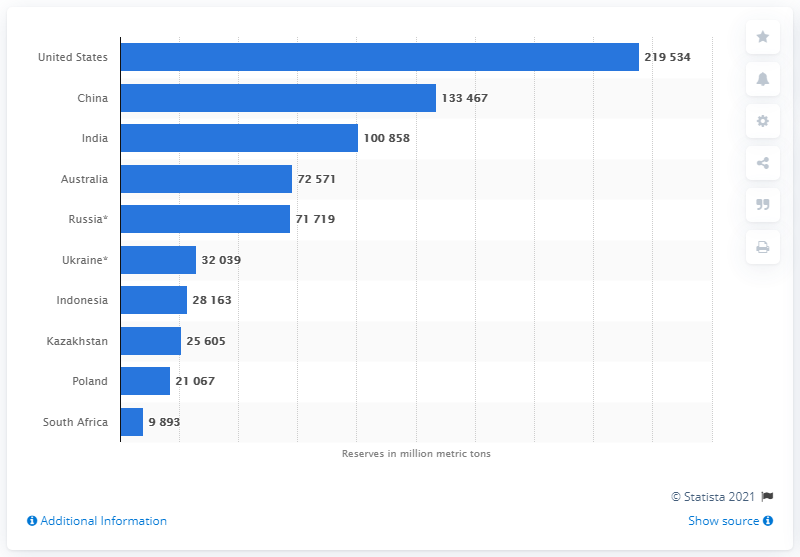Identify some key points in this picture. China is the largest producer of hard coal in the world. In 2018, the United States had a total of 219,534 short tons of hard coal. 